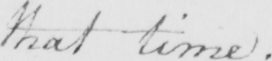Can you tell me what this handwritten text says? that time . 